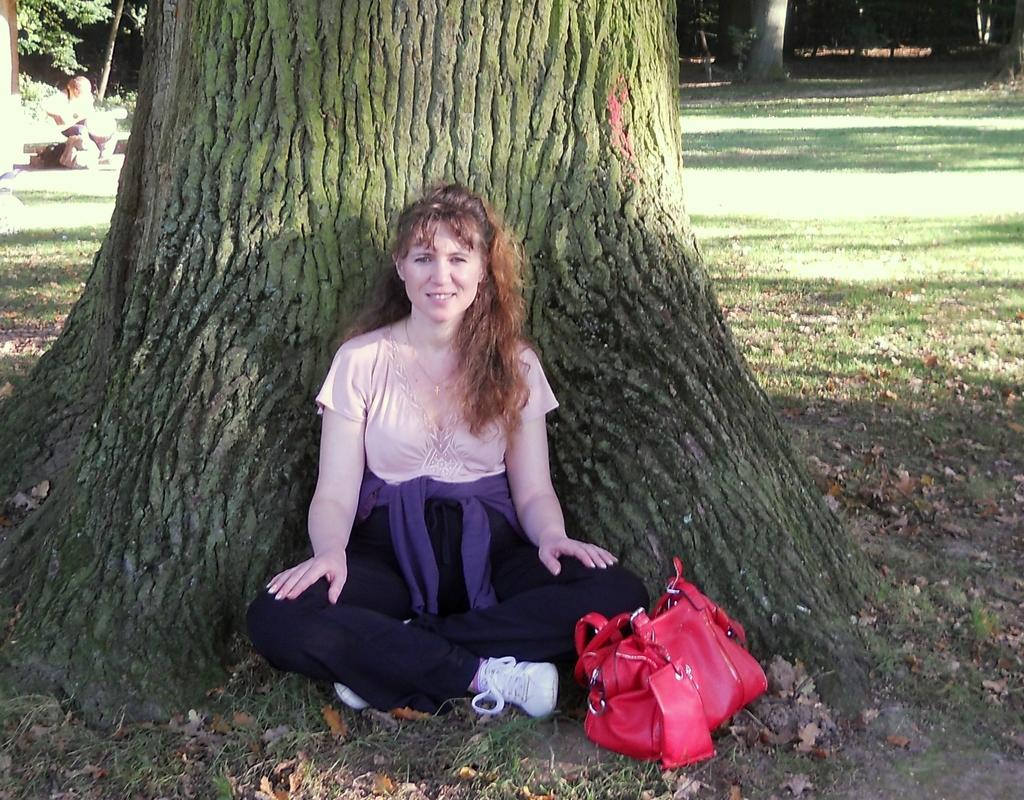Who is present in the image? There is a woman in the image. Where is the woman located in the image? The woman is sitting under a tree. What can be seen beside the woman? There is a red-colored purse beside the woman. How many trucks are parked near the woman in the image? There are no trucks visible in the image. What type of vase is placed on the tree branch in the image? There is no vase present in the image; the woman is sitting under a tree with no additional objects mentioned. 